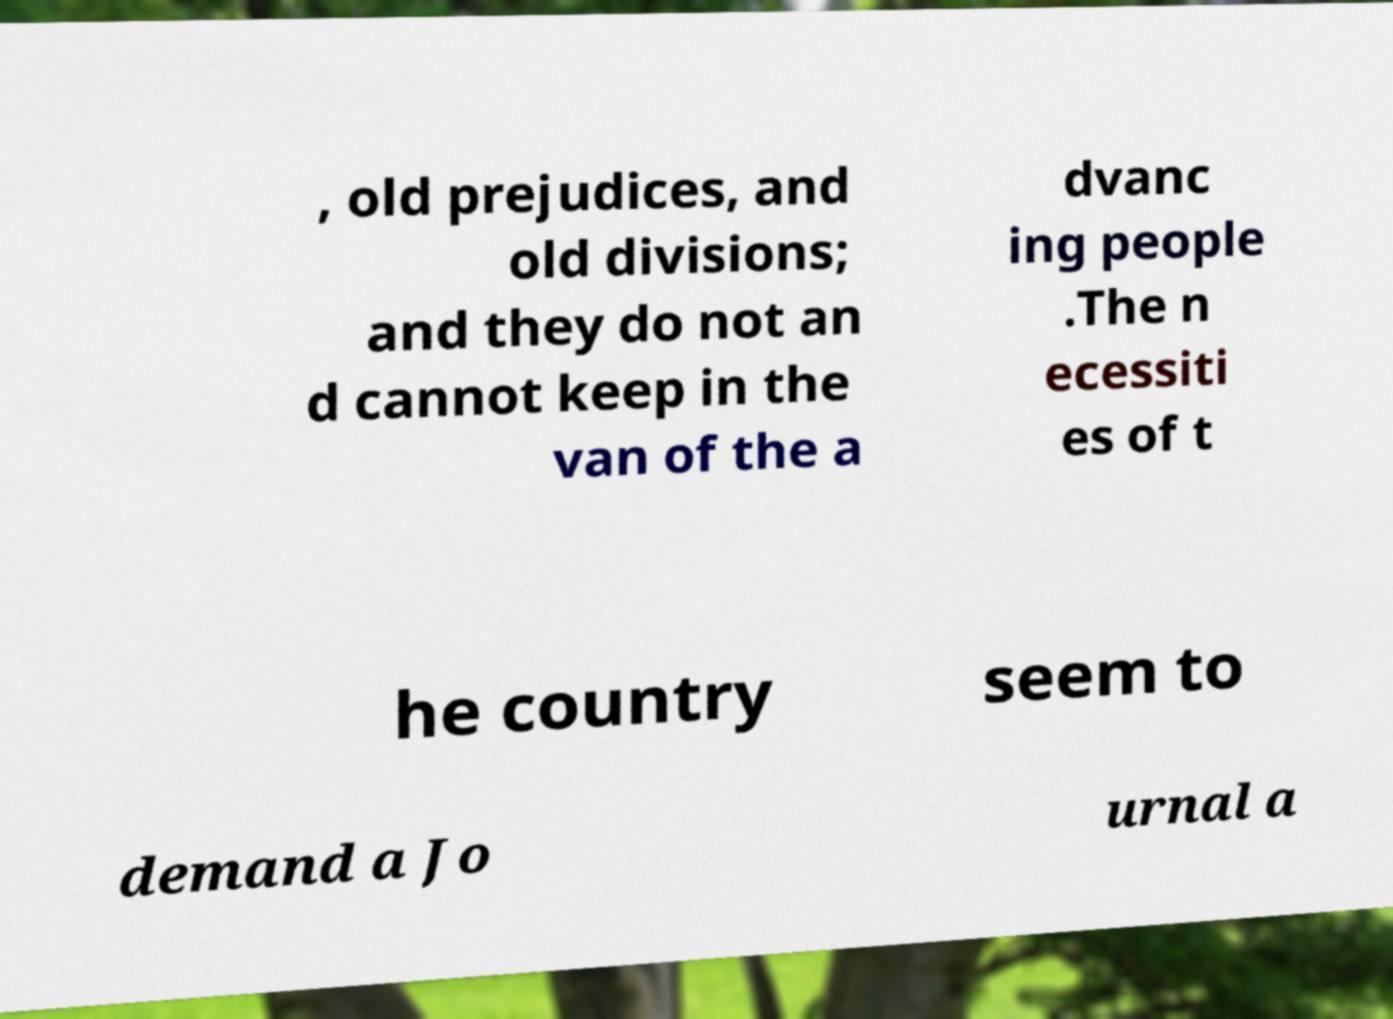For documentation purposes, I need the text within this image transcribed. Could you provide that? , old prejudices, and old divisions; and they do not an d cannot keep in the van of the a dvanc ing people .The n ecessiti es of t he country seem to demand a Jo urnal a 